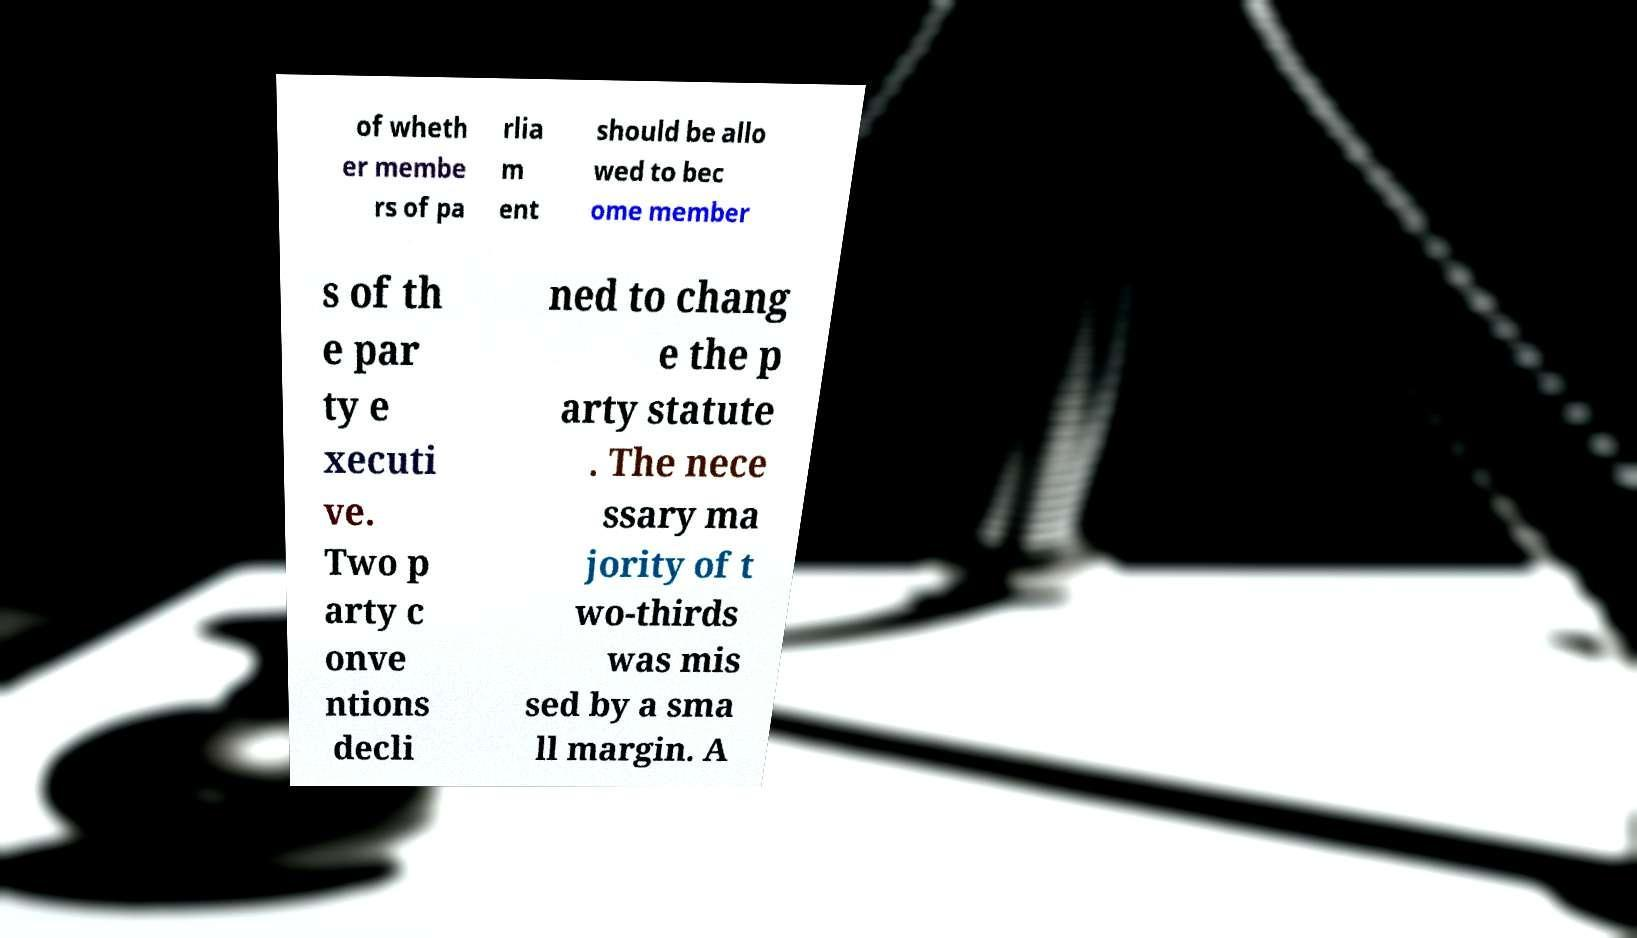Could you extract and type out the text from this image? of wheth er membe rs of pa rlia m ent should be allo wed to bec ome member s of th e par ty e xecuti ve. Two p arty c onve ntions decli ned to chang e the p arty statute . The nece ssary ma jority of t wo-thirds was mis sed by a sma ll margin. A 